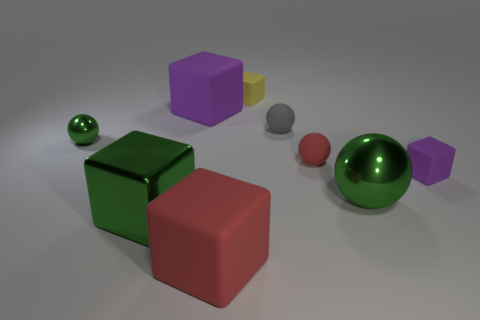Subtract all red cubes. How many cubes are left? 4 Subtract all big green cubes. How many cubes are left? 4 Subtract all gray cubes. Subtract all red balls. How many cubes are left? 5 Subtract all spheres. How many objects are left? 5 Subtract all yellow cubes. Subtract all big purple rubber blocks. How many objects are left? 7 Add 7 big green spheres. How many big green spheres are left? 8 Add 3 tiny cyan rubber blocks. How many tiny cyan rubber blocks exist? 3 Subtract 0 gray blocks. How many objects are left? 9 